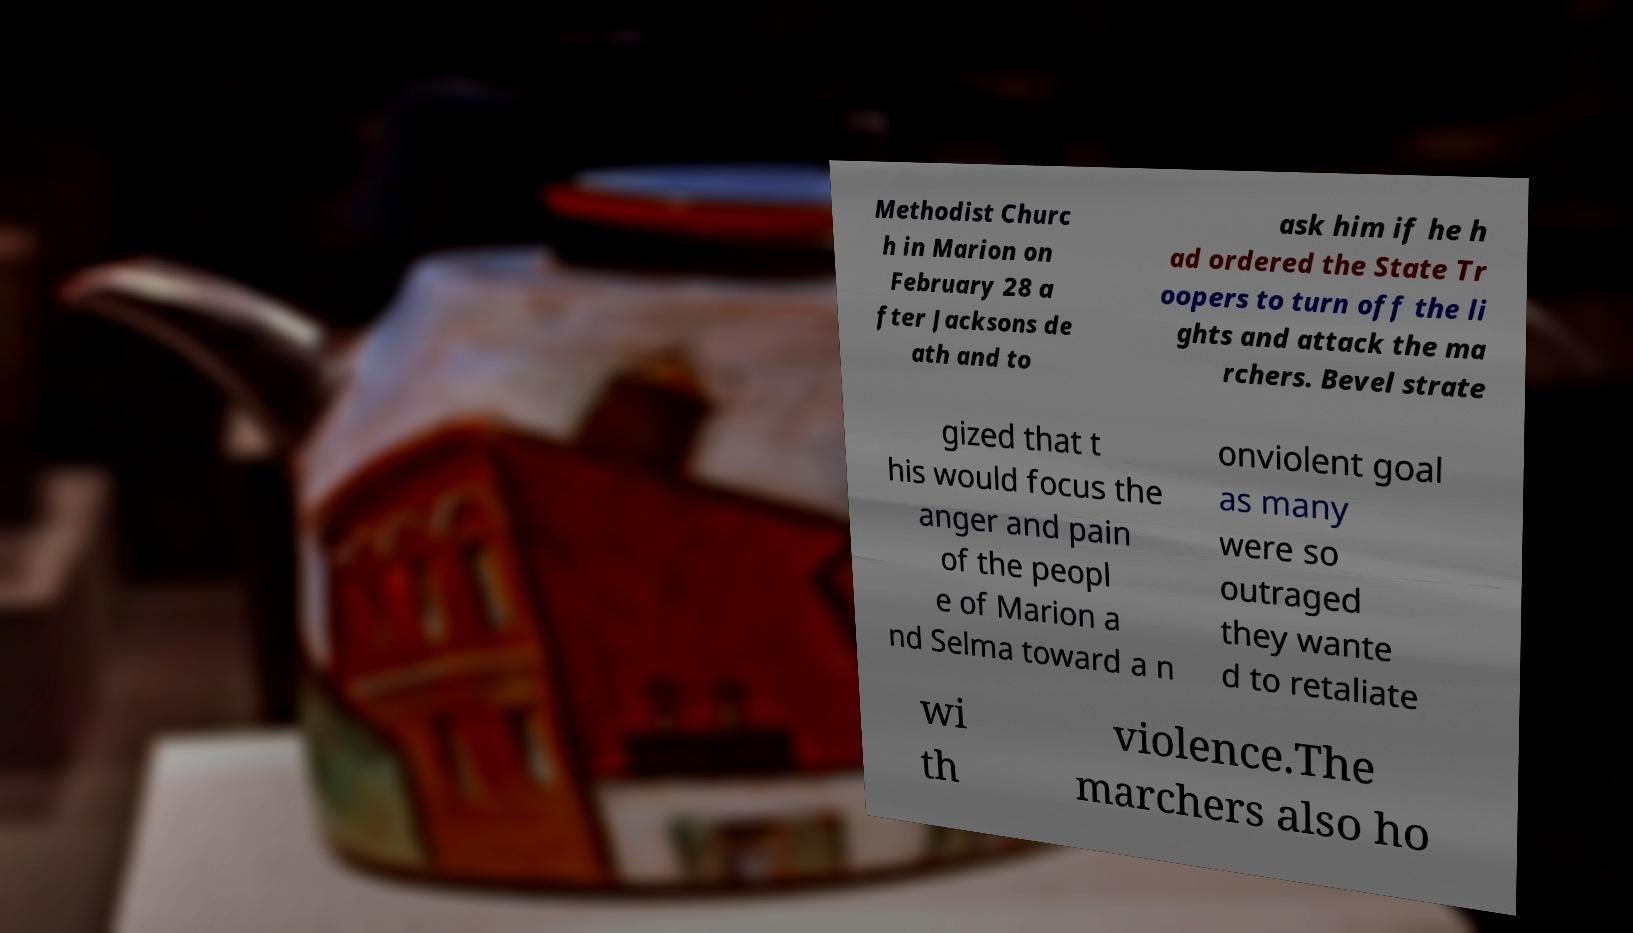Please identify and transcribe the text found in this image. Methodist Churc h in Marion on February 28 a fter Jacksons de ath and to ask him if he h ad ordered the State Tr oopers to turn off the li ghts and attack the ma rchers. Bevel strate gized that t his would focus the anger and pain of the peopl e of Marion a nd Selma toward a n onviolent goal as many were so outraged they wante d to retaliate wi th violence.The marchers also ho 